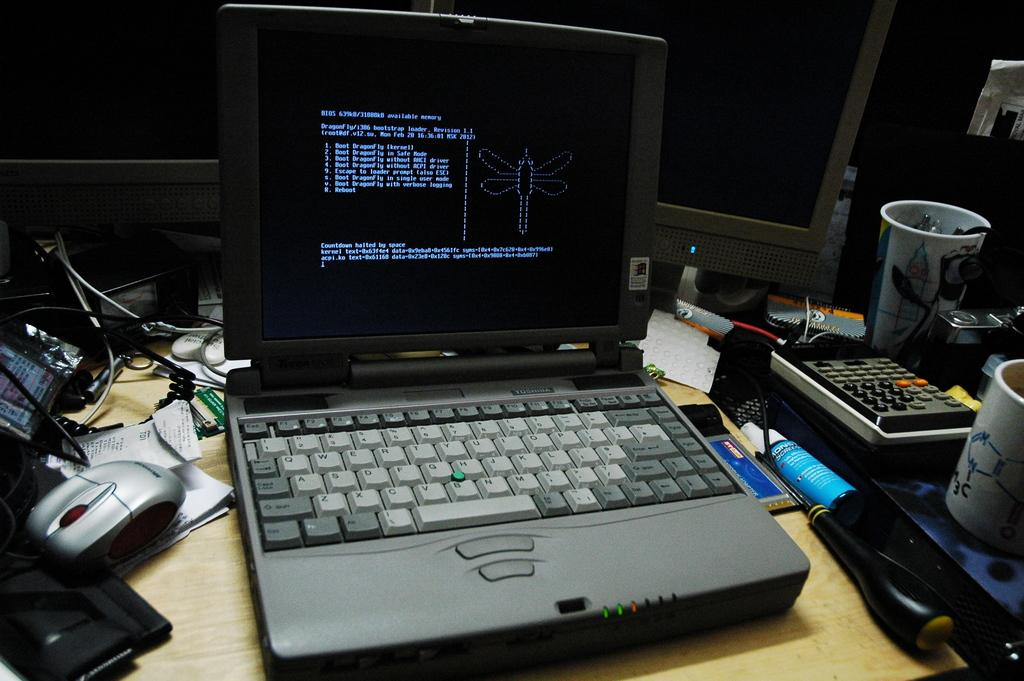What electronic device is on the table in the image? There is a laptop on the table in the image. What is another object on the table that is commonly used with a laptop? There is a mouse on the table. What type of items can be seen on the table that might be related to work or study? There are papers, a calculator, a cup, and a mug on the table. What else is on the table that might be used for holding liquids? There is a bottle on the table. What type of vegetable is growing out of the laptop in the image? There is no vegetable growing out of the laptop in the image. How far does the range of the calculator extend in the image? The calculator does not have a range that extends in the image; it is a stationary object on the table. 